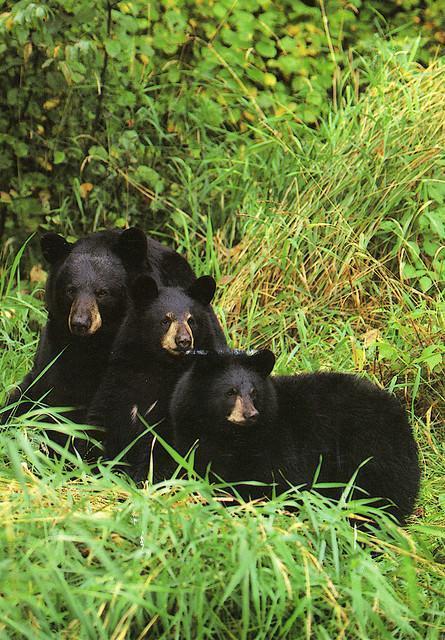How many bears are there?
Give a very brief answer. 3. How many bears are in this photo?
Give a very brief answer. 3. How many cars are there?
Give a very brief answer. 0. 